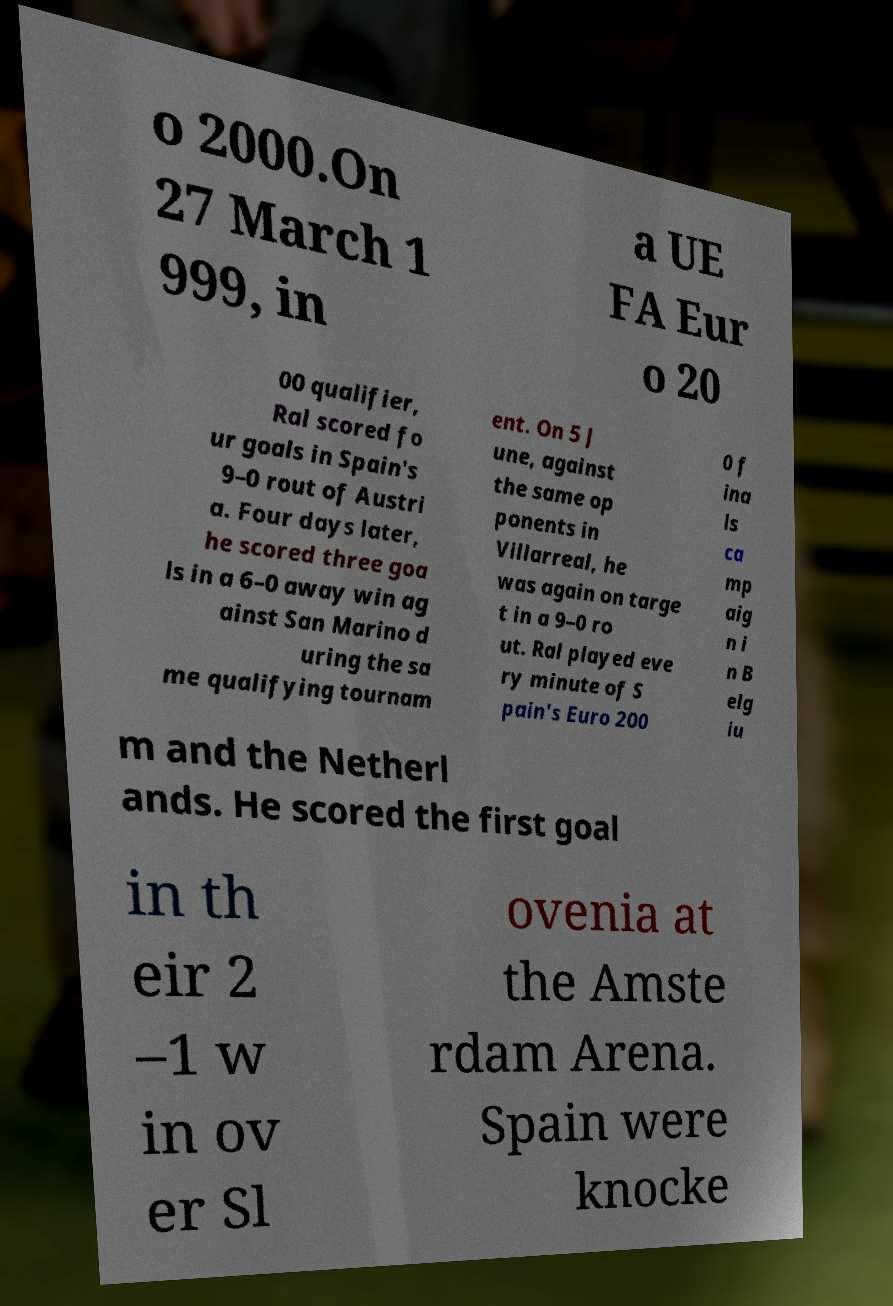Can you accurately transcribe the text from the provided image for me? o 2000.On 27 March 1 999, in a UE FA Eur o 20 00 qualifier, Ral scored fo ur goals in Spain's 9–0 rout of Austri a. Four days later, he scored three goa ls in a 6–0 away win ag ainst San Marino d uring the sa me qualifying tournam ent. On 5 J une, against the same op ponents in Villarreal, he was again on targe t in a 9–0 ro ut. Ral played eve ry minute of S pain's Euro 200 0 f ina ls ca mp aig n i n B elg iu m and the Netherl ands. He scored the first goal in th eir 2 –1 w in ov er Sl ovenia at the Amste rdam Arena. Spain were knocke 